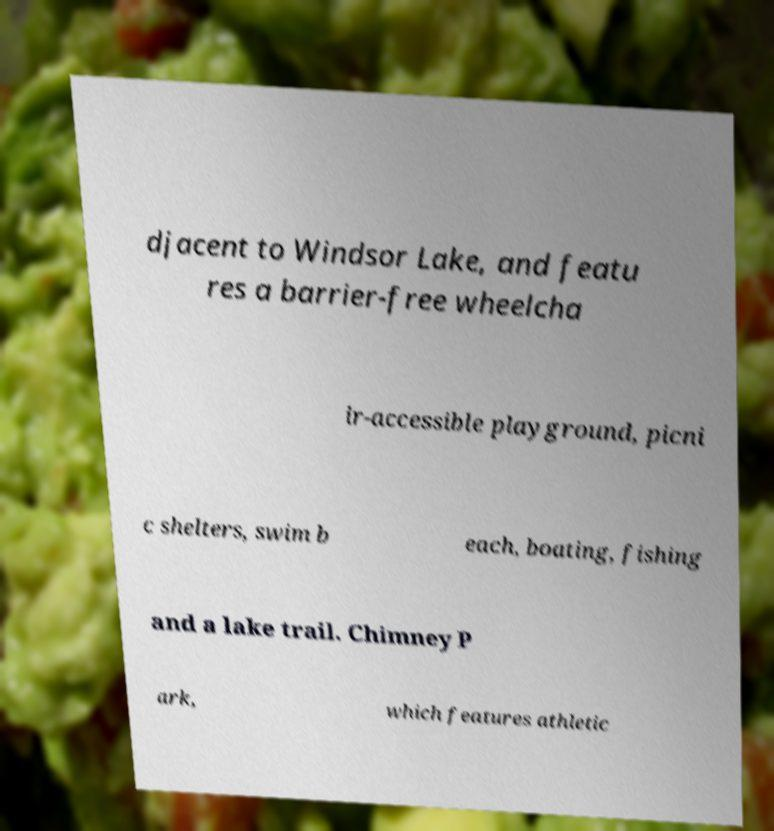Can you accurately transcribe the text from the provided image for me? djacent to Windsor Lake, and featu res a barrier-free wheelcha ir-accessible playground, picni c shelters, swim b each, boating, fishing and a lake trail. Chimney P ark, which features athletic 